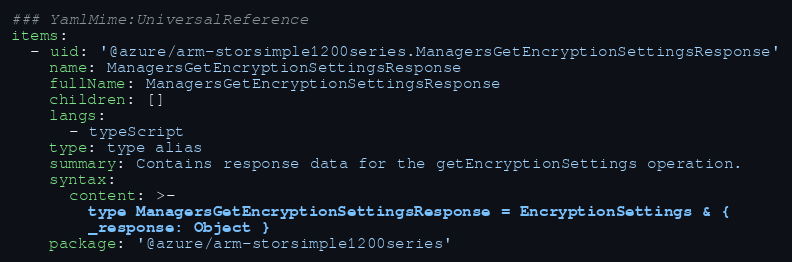<code> <loc_0><loc_0><loc_500><loc_500><_YAML_>### YamlMime:UniversalReference
items:
  - uid: '@azure/arm-storsimple1200series.ManagersGetEncryptionSettingsResponse'
    name: ManagersGetEncryptionSettingsResponse
    fullName: ManagersGetEncryptionSettingsResponse
    children: []
    langs:
      - typeScript
    type: type alias
    summary: Contains response data for the getEncryptionSettings operation.
    syntax:
      content: >-
        type ManagersGetEncryptionSettingsResponse = EncryptionSettings & {
        _response: Object }
    package: '@azure/arm-storsimple1200series'
</code> 